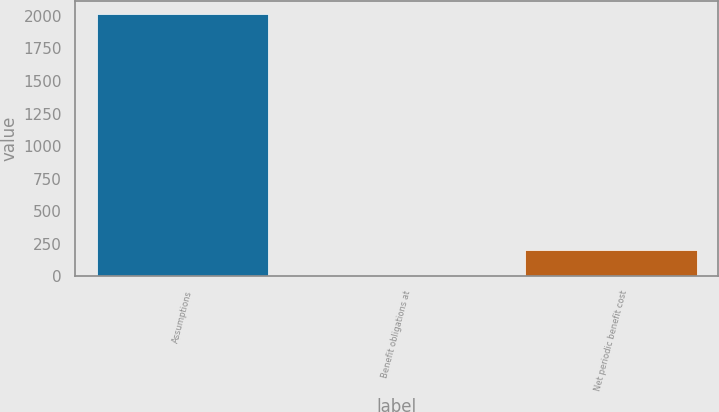Convert chart to OTSL. <chart><loc_0><loc_0><loc_500><loc_500><bar_chart><fcel>Assumptions<fcel>Benefit obligations at<fcel>Net periodic benefit cost<nl><fcel>2016<fcel>3.5<fcel>204.75<nl></chart> 